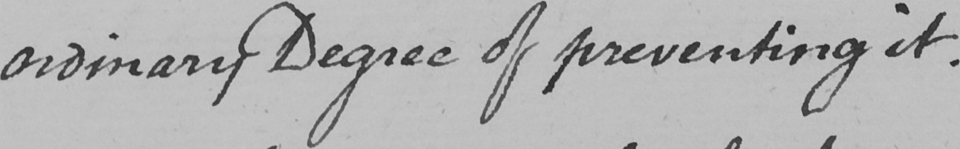Can you read and transcribe this handwriting? ordinary Degree of preventing it . 